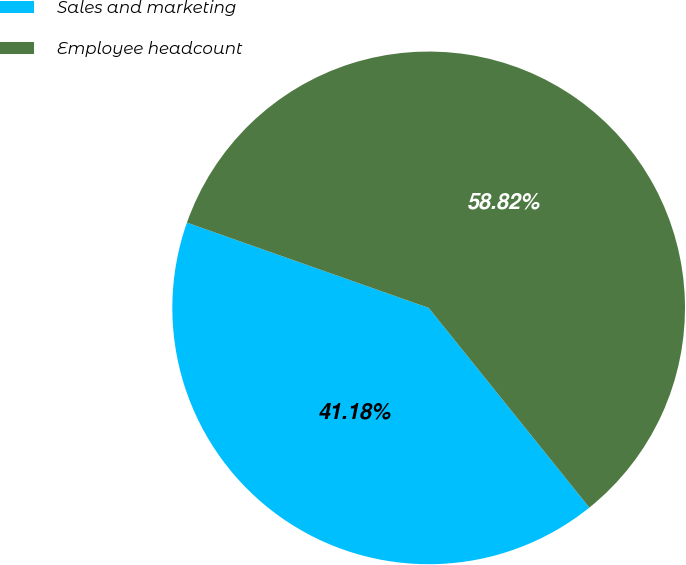Convert chart. <chart><loc_0><loc_0><loc_500><loc_500><pie_chart><fcel>Sales and marketing<fcel>Employee headcount<nl><fcel>41.18%<fcel>58.82%<nl></chart> 